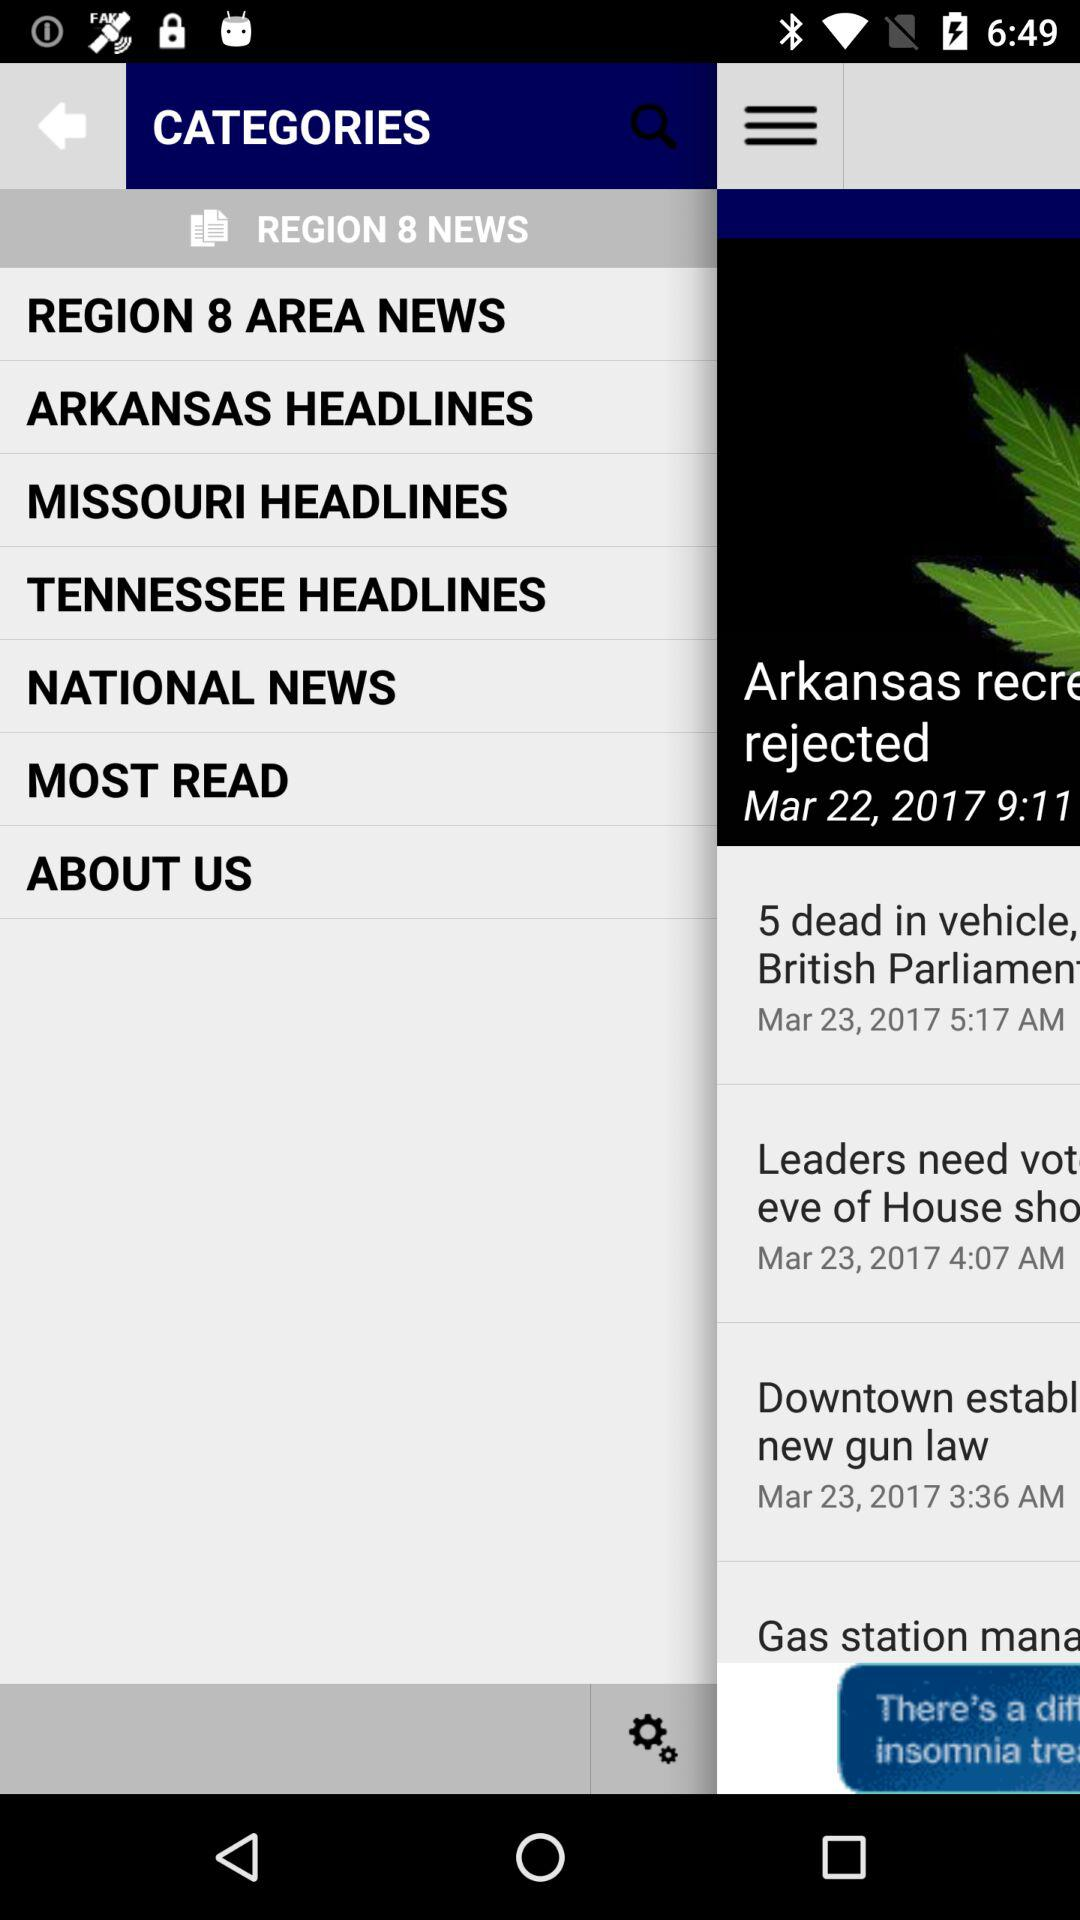What is the name of the application? The name of the application is "REGION 8 NEWS". 